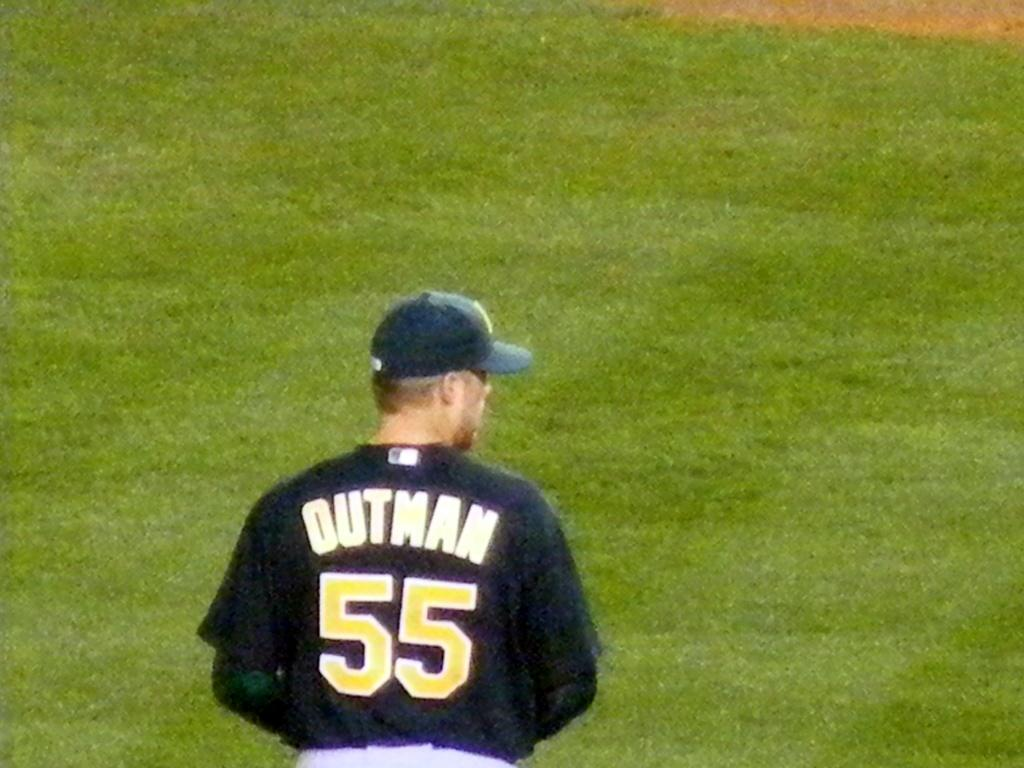Who is present in the image? There is a man in the image. What is the man wearing on his upper body? The man is wearing a navy blue jersey. What type of headwear is the man wearing? The man is wearing a cap. What type of terrain is the man standing on? The man is standing on grass land. What news is the man reading from the string in the image? There is no string or news present in the image. 